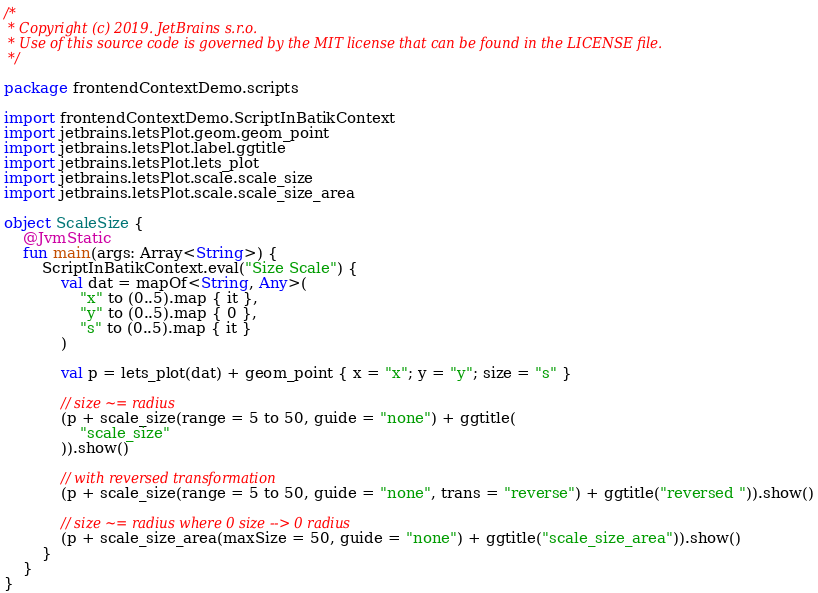Convert code to text. <code><loc_0><loc_0><loc_500><loc_500><_Kotlin_>/*
 * Copyright (c) 2019. JetBrains s.r.o.
 * Use of this source code is governed by the MIT license that can be found in the LICENSE file.
 */

package frontendContextDemo.scripts

import frontendContextDemo.ScriptInBatikContext
import jetbrains.letsPlot.geom.geom_point
import jetbrains.letsPlot.label.ggtitle
import jetbrains.letsPlot.lets_plot
import jetbrains.letsPlot.scale.scale_size
import jetbrains.letsPlot.scale.scale_size_area

object ScaleSize {
    @JvmStatic
    fun main(args: Array<String>) {
        ScriptInBatikContext.eval("Size Scale") {
            val dat = mapOf<String, Any>(
                "x" to (0..5).map { it },
                "y" to (0..5).map { 0 },
                "s" to (0..5).map { it }
            )

            val p = lets_plot(dat) + geom_point { x = "x"; y = "y"; size = "s" }

            // size ~= radius
            (p + scale_size(range = 5 to 50, guide = "none") + ggtitle(
                "scale_size"
            )).show()

            // with reversed transformation
            (p + scale_size(range = 5 to 50, guide = "none", trans = "reverse") + ggtitle("reversed ")).show()

            // size ~= radius where 0 size --> 0 radius
            (p + scale_size_area(maxSize = 50, guide = "none") + ggtitle("scale_size_area")).show()
        }
    }
}</code> 